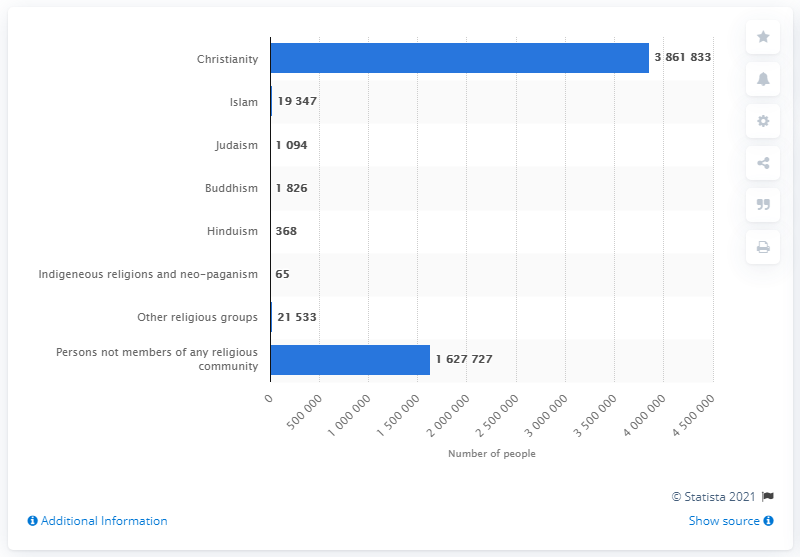Highlight a few significant elements in this photo. In 2020, there were approximately 1627,727 people in Finland who were not members of any religious community. According to a recent survey, a significant majority of people, approximately 69.79%, identify as Christians. In Finland, approximately 21,533 people belong to other religious groups. In 2020, there were approximately 386,1833 people in Finland who were members of a Christian community. According to data from 2021, approximately 1.4% of the population of Finland identifies as Muslim. 